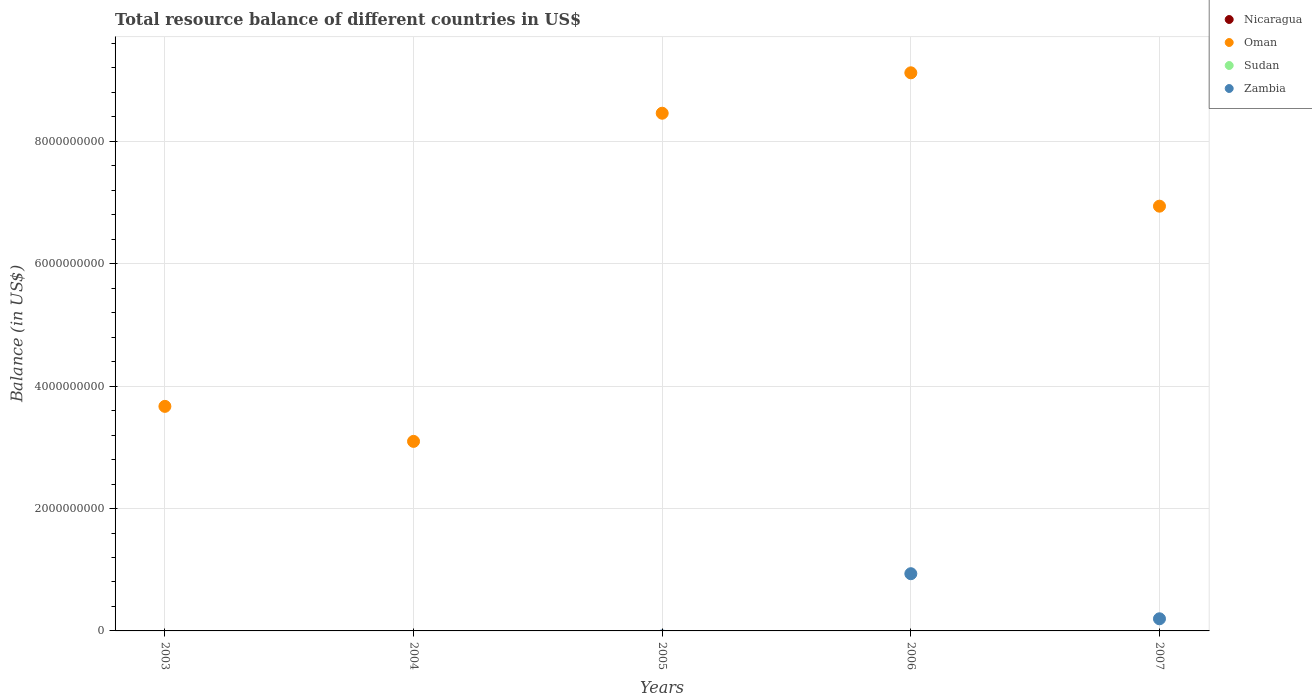Is the number of dotlines equal to the number of legend labels?
Offer a terse response. No. What is the total resource balance in Nicaragua in 2005?
Provide a succinct answer. 0. Across all years, what is the maximum total resource balance in Oman?
Ensure brevity in your answer.  9.12e+09. Across all years, what is the minimum total resource balance in Nicaragua?
Make the answer very short. 0. In which year was the total resource balance in Oman maximum?
Provide a succinct answer. 2006. What is the total total resource balance in Oman in the graph?
Your answer should be very brief. 3.13e+1. What is the difference between the total resource balance in Oman in 2003 and that in 2007?
Ensure brevity in your answer.  -3.27e+09. In the year 2006, what is the difference between the total resource balance in Oman and total resource balance in Zambia?
Provide a succinct answer. 8.19e+09. What is the ratio of the total resource balance in Oman in 2005 to that in 2006?
Ensure brevity in your answer.  0.93. Is the total resource balance in Oman in 2005 less than that in 2006?
Your answer should be very brief. Yes. Is the difference between the total resource balance in Oman in 2006 and 2007 greater than the difference between the total resource balance in Zambia in 2006 and 2007?
Provide a succinct answer. Yes. What is the difference between the highest and the second highest total resource balance in Oman?
Your answer should be very brief. 6.61e+08. What is the difference between the highest and the lowest total resource balance in Zambia?
Your answer should be compact. 9.35e+08. Is it the case that in every year, the sum of the total resource balance in Nicaragua and total resource balance in Oman  is greater than the sum of total resource balance in Zambia and total resource balance in Sudan?
Your answer should be compact. Yes. Does the total resource balance in Nicaragua monotonically increase over the years?
Keep it short and to the point. No. How many dotlines are there?
Make the answer very short. 2. What is the difference between two consecutive major ticks on the Y-axis?
Offer a very short reply. 2.00e+09. Does the graph contain any zero values?
Your response must be concise. Yes. Does the graph contain grids?
Give a very brief answer. Yes. Where does the legend appear in the graph?
Your answer should be compact. Top right. How many legend labels are there?
Provide a succinct answer. 4. How are the legend labels stacked?
Give a very brief answer. Vertical. What is the title of the graph?
Ensure brevity in your answer.  Total resource balance of different countries in US$. Does "Costa Rica" appear as one of the legend labels in the graph?
Ensure brevity in your answer.  No. What is the label or title of the X-axis?
Your answer should be compact. Years. What is the label or title of the Y-axis?
Make the answer very short. Balance (in US$). What is the Balance (in US$) of Nicaragua in 2003?
Provide a succinct answer. 0. What is the Balance (in US$) of Oman in 2003?
Make the answer very short. 3.67e+09. What is the Balance (in US$) of Zambia in 2003?
Provide a succinct answer. 0. What is the Balance (in US$) in Oman in 2004?
Make the answer very short. 3.10e+09. What is the Balance (in US$) of Sudan in 2004?
Make the answer very short. 0. What is the Balance (in US$) of Oman in 2005?
Make the answer very short. 8.46e+09. What is the Balance (in US$) in Sudan in 2005?
Keep it short and to the point. 0. What is the Balance (in US$) in Oman in 2006?
Your answer should be very brief. 9.12e+09. What is the Balance (in US$) of Sudan in 2006?
Offer a very short reply. 0. What is the Balance (in US$) in Zambia in 2006?
Offer a terse response. 9.35e+08. What is the Balance (in US$) of Oman in 2007?
Give a very brief answer. 6.94e+09. What is the Balance (in US$) in Zambia in 2007?
Your answer should be compact. 1.98e+08. Across all years, what is the maximum Balance (in US$) in Oman?
Offer a terse response. 9.12e+09. Across all years, what is the maximum Balance (in US$) in Zambia?
Provide a succinct answer. 9.35e+08. Across all years, what is the minimum Balance (in US$) in Oman?
Offer a very short reply. 3.10e+09. What is the total Balance (in US$) in Oman in the graph?
Make the answer very short. 3.13e+1. What is the total Balance (in US$) in Zambia in the graph?
Give a very brief answer. 1.13e+09. What is the difference between the Balance (in US$) of Oman in 2003 and that in 2004?
Your response must be concise. 5.72e+08. What is the difference between the Balance (in US$) in Oman in 2003 and that in 2005?
Make the answer very short. -4.79e+09. What is the difference between the Balance (in US$) in Oman in 2003 and that in 2006?
Offer a very short reply. -5.45e+09. What is the difference between the Balance (in US$) in Oman in 2003 and that in 2007?
Give a very brief answer. -3.27e+09. What is the difference between the Balance (in US$) in Oman in 2004 and that in 2005?
Ensure brevity in your answer.  -5.36e+09. What is the difference between the Balance (in US$) in Oman in 2004 and that in 2006?
Your response must be concise. -6.02e+09. What is the difference between the Balance (in US$) of Oman in 2004 and that in 2007?
Keep it short and to the point. -3.84e+09. What is the difference between the Balance (in US$) in Oman in 2005 and that in 2006?
Provide a succinct answer. -6.61e+08. What is the difference between the Balance (in US$) of Oman in 2005 and that in 2007?
Your answer should be very brief. 1.52e+09. What is the difference between the Balance (in US$) in Oman in 2006 and that in 2007?
Ensure brevity in your answer.  2.18e+09. What is the difference between the Balance (in US$) in Zambia in 2006 and that in 2007?
Your response must be concise. 7.37e+08. What is the difference between the Balance (in US$) of Oman in 2003 and the Balance (in US$) of Zambia in 2006?
Keep it short and to the point. 2.73e+09. What is the difference between the Balance (in US$) in Oman in 2003 and the Balance (in US$) in Zambia in 2007?
Give a very brief answer. 3.47e+09. What is the difference between the Balance (in US$) in Oman in 2004 and the Balance (in US$) in Zambia in 2006?
Make the answer very short. 2.16e+09. What is the difference between the Balance (in US$) of Oman in 2004 and the Balance (in US$) of Zambia in 2007?
Offer a terse response. 2.90e+09. What is the difference between the Balance (in US$) of Oman in 2005 and the Balance (in US$) of Zambia in 2006?
Your answer should be compact. 7.53e+09. What is the difference between the Balance (in US$) of Oman in 2005 and the Balance (in US$) of Zambia in 2007?
Provide a short and direct response. 8.26e+09. What is the difference between the Balance (in US$) of Oman in 2006 and the Balance (in US$) of Zambia in 2007?
Your answer should be compact. 8.92e+09. What is the average Balance (in US$) in Oman per year?
Give a very brief answer. 6.26e+09. What is the average Balance (in US$) in Sudan per year?
Offer a very short reply. 0. What is the average Balance (in US$) in Zambia per year?
Ensure brevity in your answer.  2.27e+08. In the year 2006, what is the difference between the Balance (in US$) of Oman and Balance (in US$) of Zambia?
Provide a succinct answer. 8.19e+09. In the year 2007, what is the difference between the Balance (in US$) in Oman and Balance (in US$) in Zambia?
Offer a very short reply. 6.74e+09. What is the ratio of the Balance (in US$) of Oman in 2003 to that in 2004?
Provide a succinct answer. 1.18. What is the ratio of the Balance (in US$) in Oman in 2003 to that in 2005?
Your answer should be compact. 0.43. What is the ratio of the Balance (in US$) of Oman in 2003 to that in 2006?
Your response must be concise. 0.4. What is the ratio of the Balance (in US$) of Oman in 2003 to that in 2007?
Ensure brevity in your answer.  0.53. What is the ratio of the Balance (in US$) of Oman in 2004 to that in 2005?
Provide a short and direct response. 0.37. What is the ratio of the Balance (in US$) of Oman in 2004 to that in 2006?
Keep it short and to the point. 0.34. What is the ratio of the Balance (in US$) of Oman in 2004 to that in 2007?
Ensure brevity in your answer.  0.45. What is the ratio of the Balance (in US$) in Oman in 2005 to that in 2006?
Offer a very short reply. 0.93. What is the ratio of the Balance (in US$) in Oman in 2005 to that in 2007?
Keep it short and to the point. 1.22. What is the ratio of the Balance (in US$) of Oman in 2006 to that in 2007?
Provide a short and direct response. 1.31. What is the ratio of the Balance (in US$) in Zambia in 2006 to that in 2007?
Provide a short and direct response. 4.71. What is the difference between the highest and the second highest Balance (in US$) of Oman?
Provide a succinct answer. 6.61e+08. What is the difference between the highest and the lowest Balance (in US$) of Oman?
Provide a succinct answer. 6.02e+09. What is the difference between the highest and the lowest Balance (in US$) of Zambia?
Ensure brevity in your answer.  9.35e+08. 